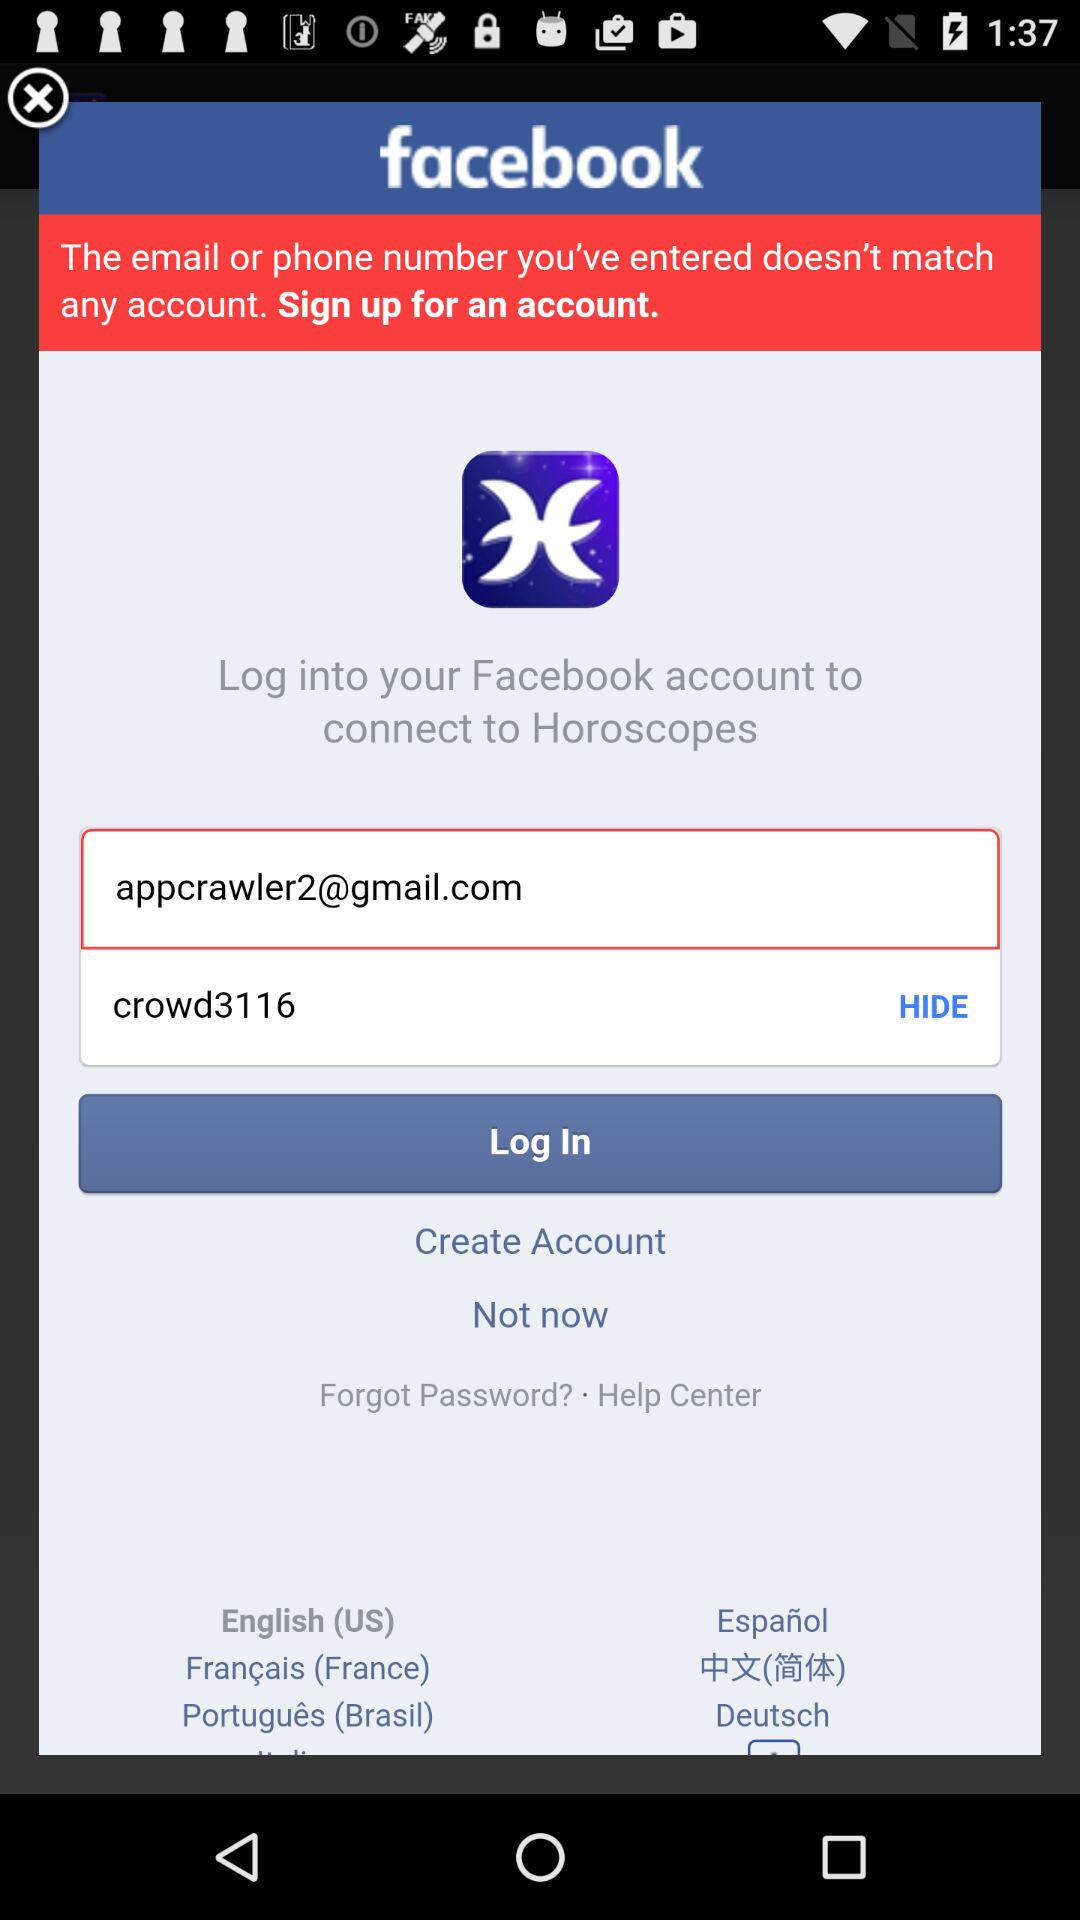How many languages are available for the user to choose from?
Answer the question using a single word or phrase. 6 